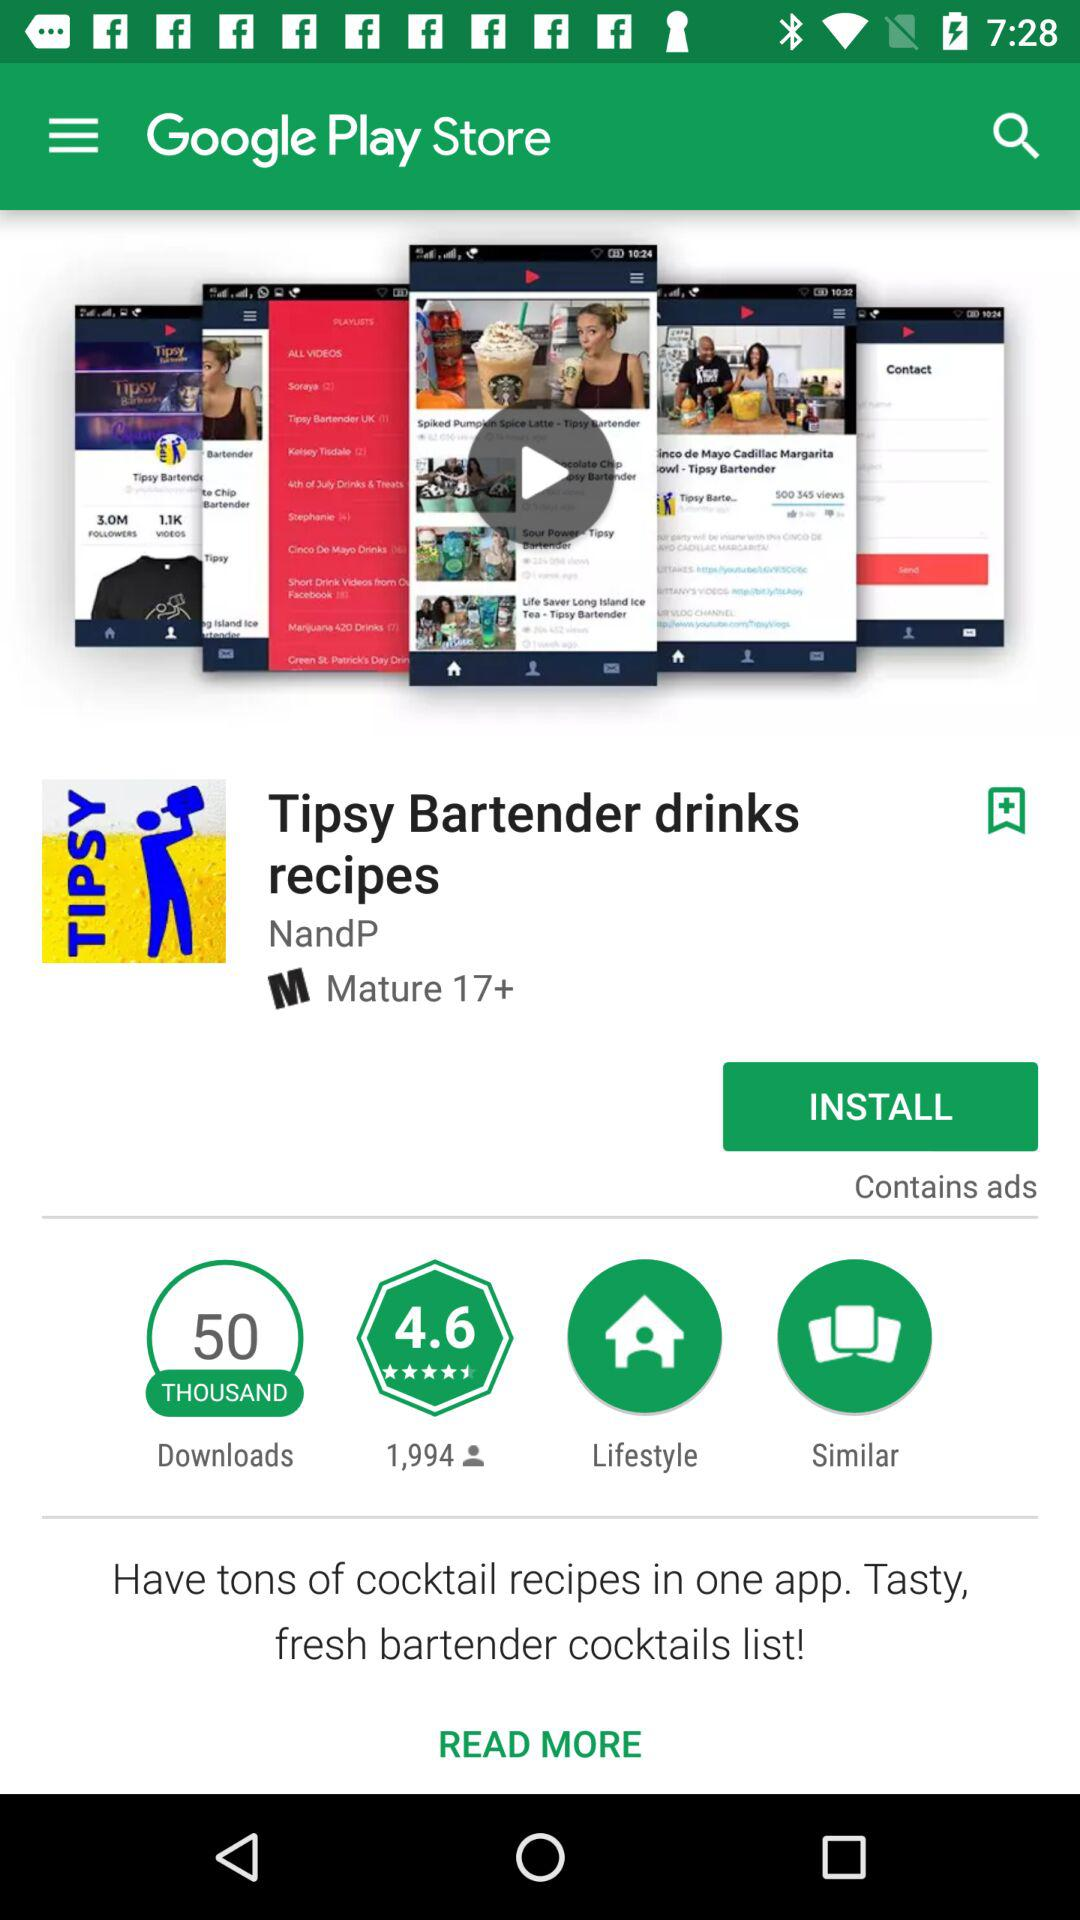What is the age rating for the "Tipsy Bartender drinks recipes" application? The age rating is "Mature 17+". 